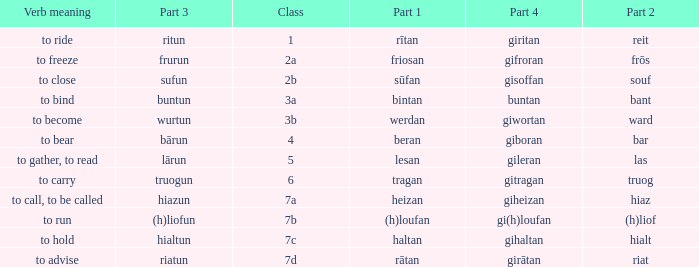What is the verb meaning of the word with part 3 "sufun"? To close. 